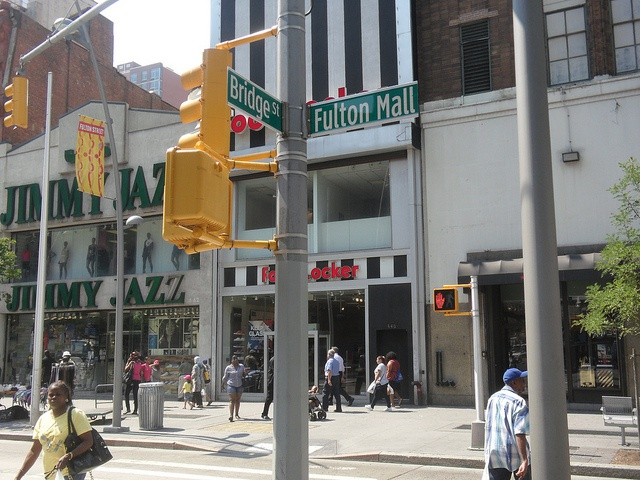Describe the objects in this image and their specific colors. I can see traffic light in gray, olive, and tan tones, people in gray, white, darkgray, and black tones, people in gray, black, darkgray, and lightgray tones, people in gray, tan, beige, and maroon tones, and handbag in gray and black tones in this image. 